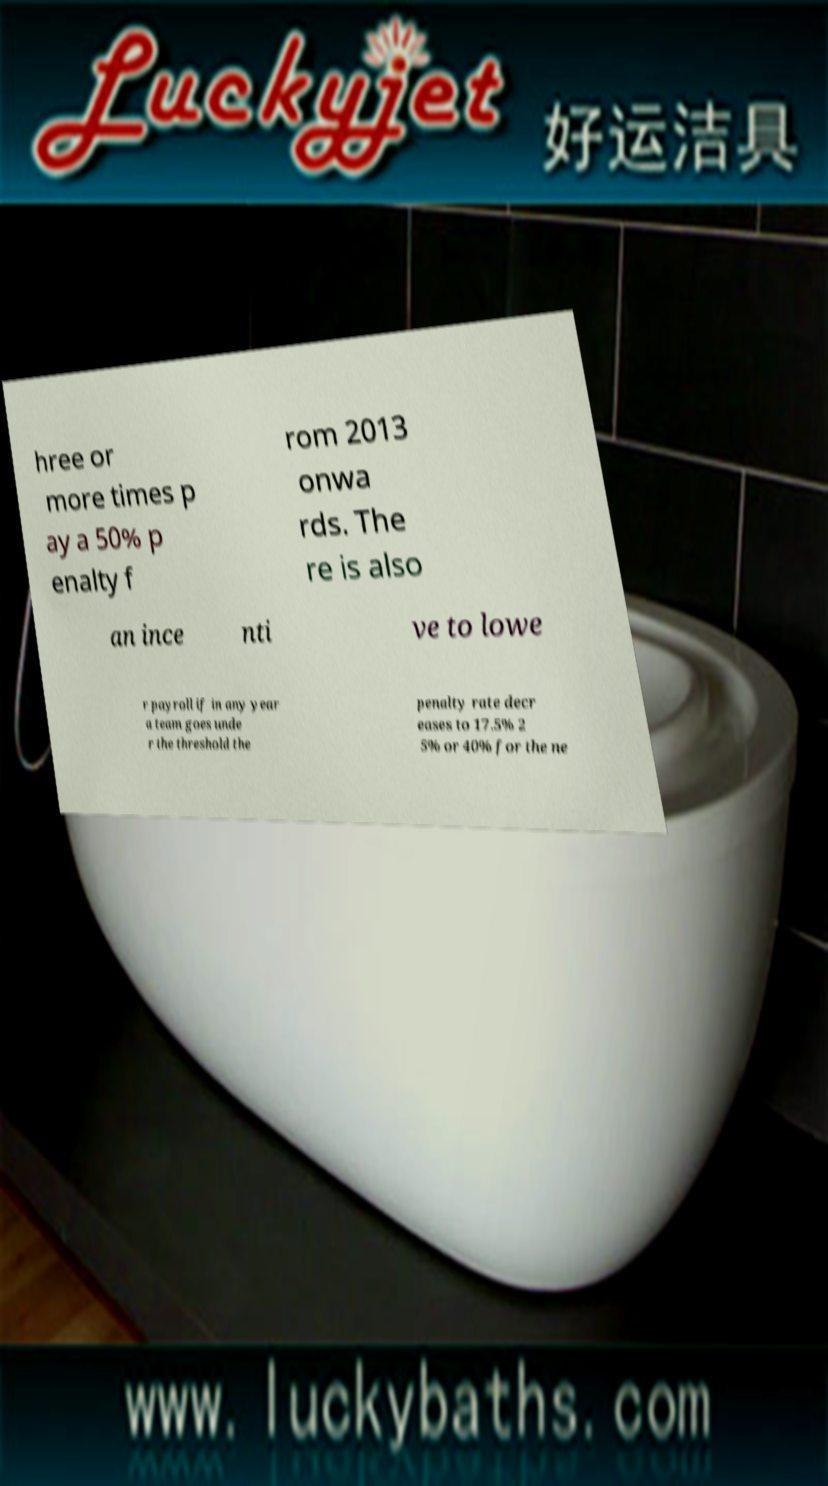Could you extract and type out the text from this image? hree or more times p ay a 50% p enalty f rom 2013 onwa rds. The re is also an ince nti ve to lowe r payroll if in any year a team goes unde r the threshold the penalty rate decr eases to 17.5% 2 5% or 40% for the ne 